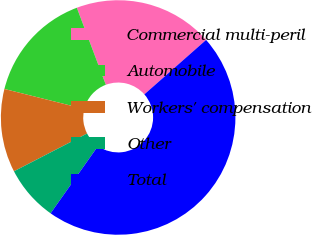<chart> <loc_0><loc_0><loc_500><loc_500><pie_chart><fcel>Commercial multi-peril<fcel>Automobile<fcel>Workers' compensation<fcel>Other<fcel>Total<nl><fcel>19.23%<fcel>15.36%<fcel>11.5%<fcel>7.64%<fcel>46.27%<nl></chart> 